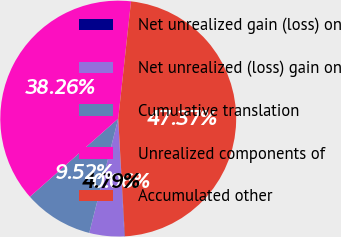Convert chart to OTSL. <chart><loc_0><loc_0><loc_500><loc_500><pie_chart><fcel>Net unrealized gain (loss) on<fcel>Net unrealized (loss) gain on<fcel>Cumulative translation<fcel>Unrealized components of<fcel>Accumulated other<nl><fcel>0.06%<fcel>4.79%<fcel>9.52%<fcel>38.26%<fcel>47.37%<nl></chart> 